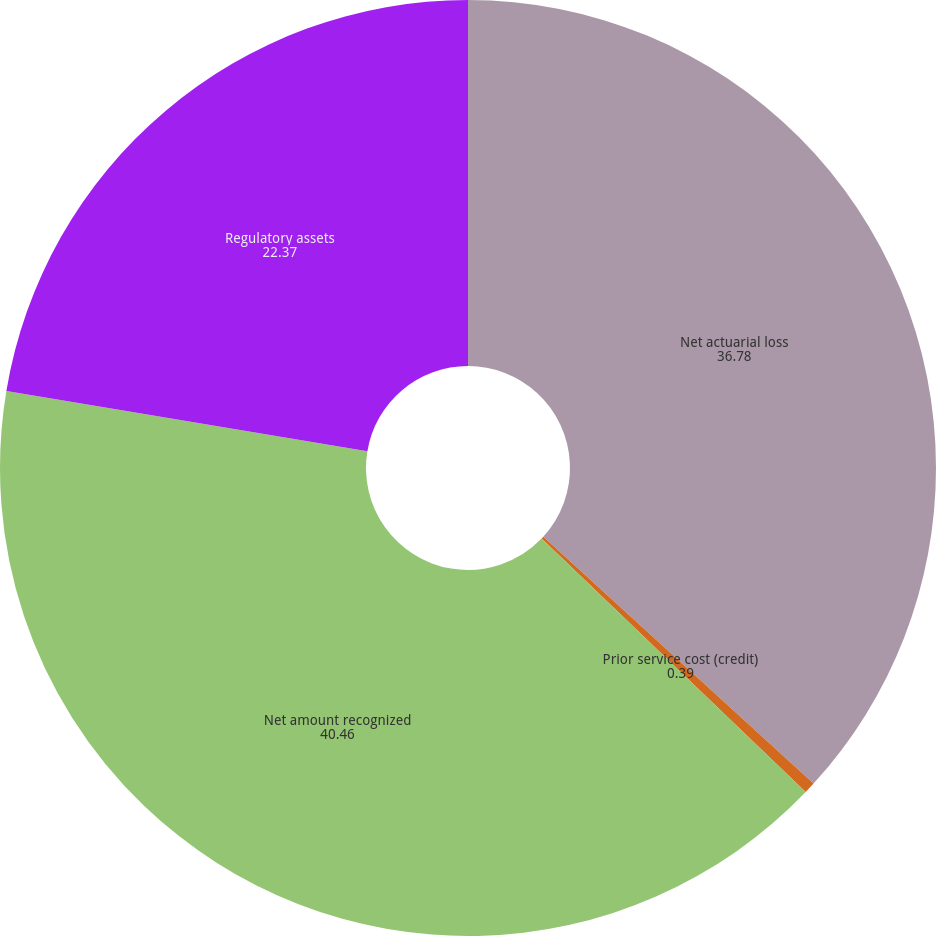Convert chart to OTSL. <chart><loc_0><loc_0><loc_500><loc_500><pie_chart><fcel>Net actuarial loss<fcel>Prior service cost (credit)<fcel>Net amount recognized<fcel>Regulatory assets<nl><fcel>36.78%<fcel>0.39%<fcel>40.46%<fcel>22.37%<nl></chart> 